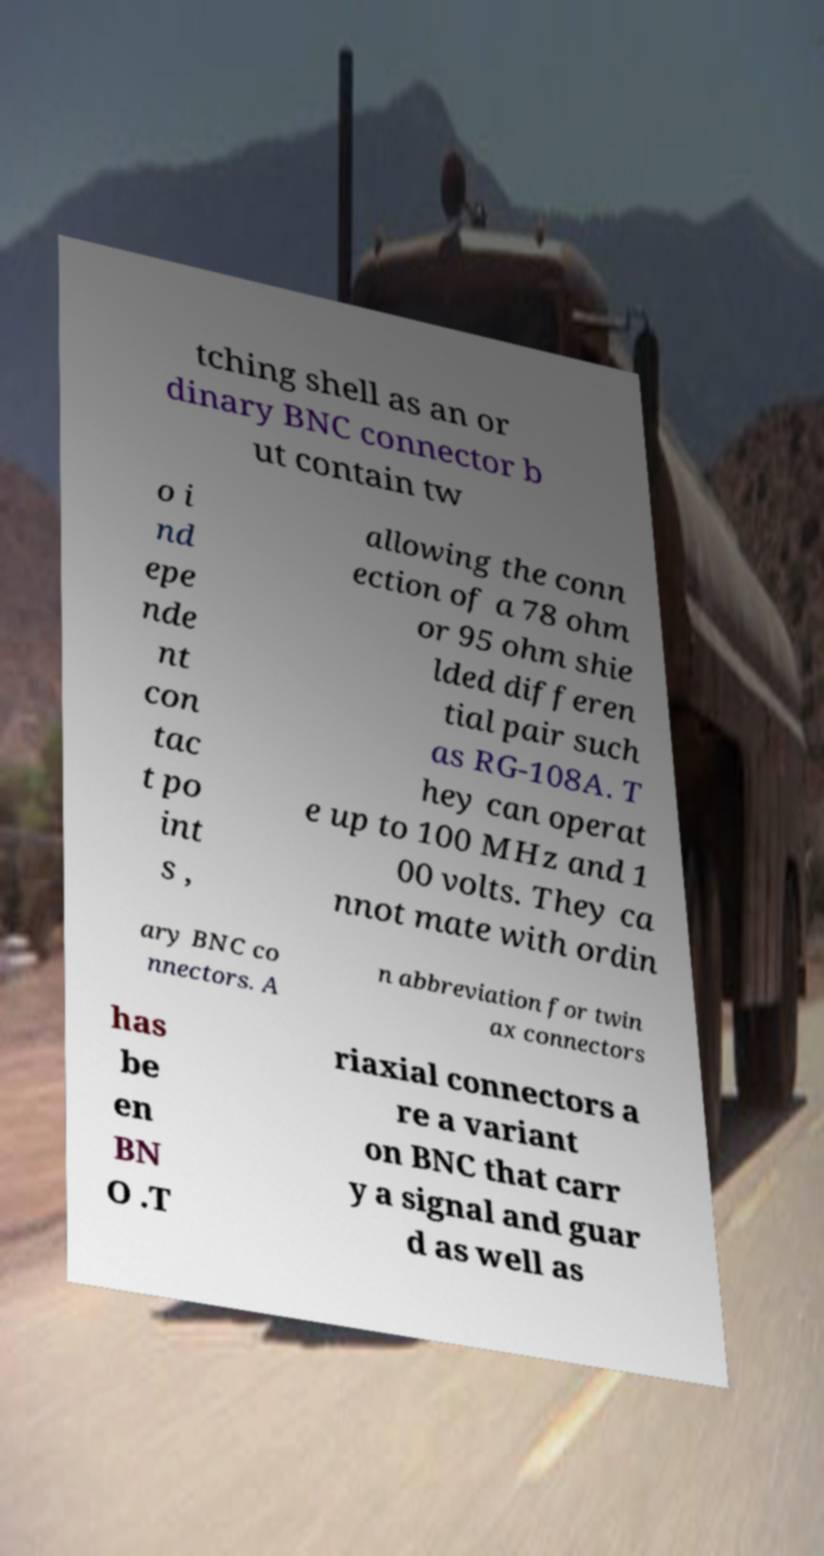For documentation purposes, I need the text within this image transcribed. Could you provide that? tching shell as an or dinary BNC connector b ut contain tw o i nd epe nde nt con tac t po int s , allowing the conn ection of a 78 ohm or 95 ohm shie lded differen tial pair such as RG-108A. T hey can operat e up to 100 MHz and 1 00 volts. They ca nnot mate with ordin ary BNC co nnectors. A n abbreviation for twin ax connectors has be en BN O .T riaxial connectors a re a variant on BNC that carr y a signal and guar d as well as 